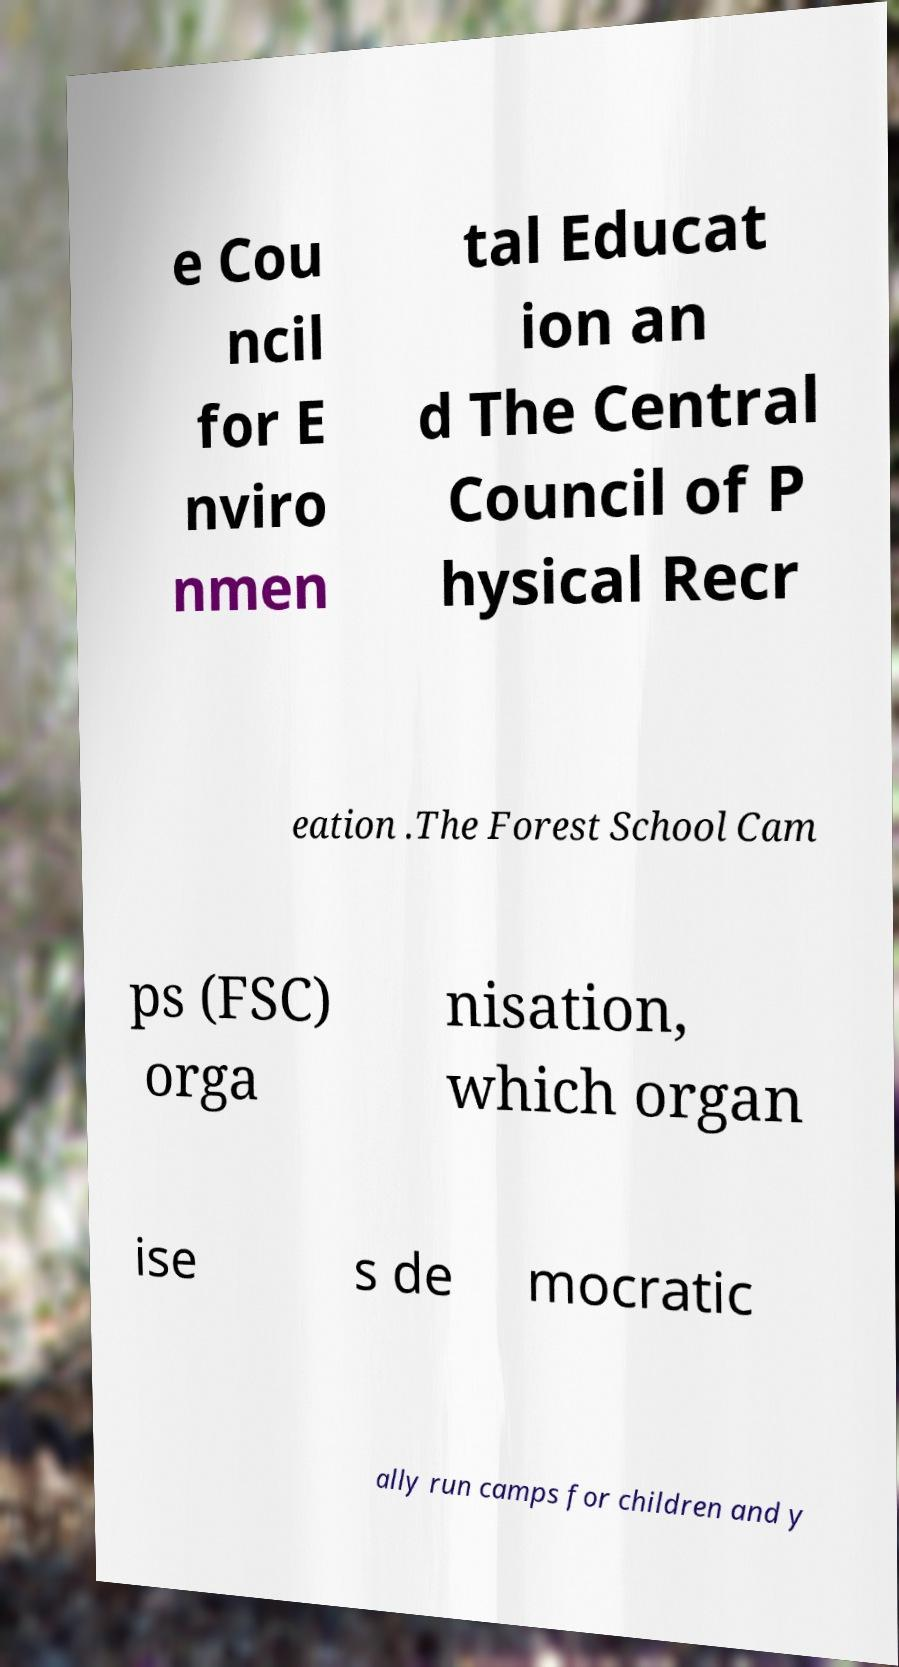Please read and relay the text visible in this image. What does it say? e Cou ncil for E nviro nmen tal Educat ion an d The Central Council of P hysical Recr eation .The Forest School Cam ps (FSC) orga nisation, which organ ise s de mocratic ally run camps for children and y 